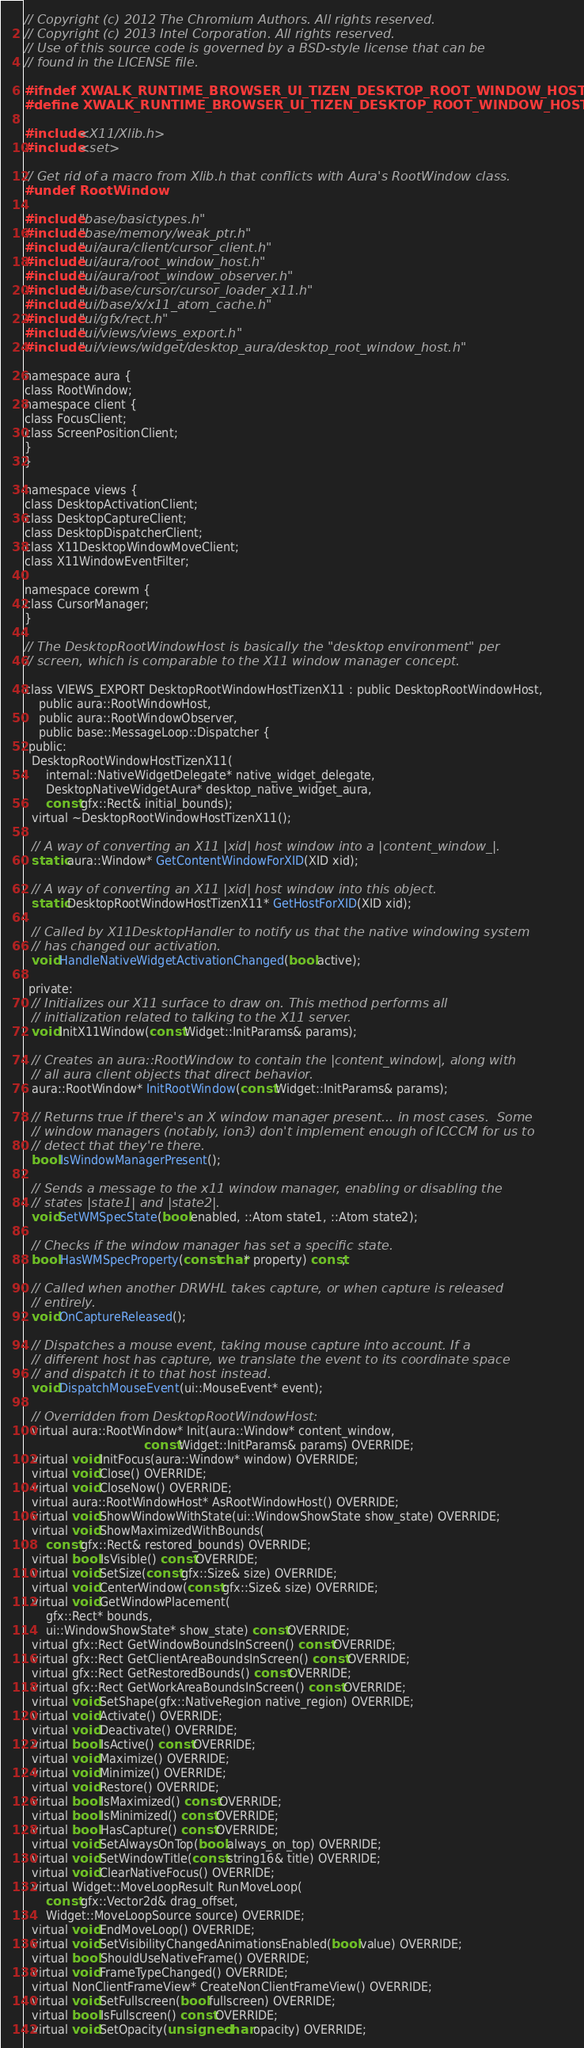<code> <loc_0><loc_0><loc_500><loc_500><_C_>// Copyright (c) 2012 The Chromium Authors. All rights reserved.
// Copyright (c) 2013 Intel Corporation. All rights reserved.
// Use of this source code is governed by a BSD-style license that can be
// found in the LICENSE file.

#ifndef XWALK_RUNTIME_BROWSER_UI_TIZEN_DESKTOP_ROOT_WINDOW_HOST_TIZEN_X11_H_
#define XWALK_RUNTIME_BROWSER_UI_TIZEN_DESKTOP_ROOT_WINDOW_HOST_TIZEN_X11_H_

#include <X11/Xlib.h>
#include <set>

// Get rid of a macro from Xlib.h that conflicts with Aura's RootWindow class.
#undef RootWindow

#include "base/basictypes.h"
#include "base/memory/weak_ptr.h"
#include "ui/aura/client/cursor_client.h"
#include "ui/aura/root_window_host.h"
#include "ui/aura/root_window_observer.h"
#include "ui/base/cursor/cursor_loader_x11.h"
#include "ui/base/x/x11_atom_cache.h"
#include "ui/gfx/rect.h"
#include "ui/views/views_export.h"
#include "ui/views/widget/desktop_aura/desktop_root_window_host.h"

namespace aura {
class RootWindow;
namespace client {
class FocusClient;
class ScreenPositionClient;
}
}

namespace views {
class DesktopActivationClient;
class DesktopCaptureClient;
class DesktopDispatcherClient;
class X11DesktopWindowMoveClient;
class X11WindowEventFilter;

namespace corewm {
class CursorManager;
}

// The DesktopRootWindowHost is basically the "desktop environment" per
// screen, which is comparable to the X11 window manager concept.

class VIEWS_EXPORT DesktopRootWindowHostTizenX11 : public DesktopRootWindowHost,
    public aura::RootWindowHost,
    public aura::RootWindowObserver,
    public base::MessageLoop::Dispatcher {
 public:
  DesktopRootWindowHostTizenX11(
      internal::NativeWidgetDelegate* native_widget_delegate,
      DesktopNativeWidgetAura* desktop_native_widget_aura,
      const gfx::Rect& initial_bounds);
  virtual ~DesktopRootWindowHostTizenX11();

  // A way of converting an X11 |xid| host window into a |content_window_|.
  static aura::Window* GetContentWindowForXID(XID xid);

  // A way of converting an X11 |xid| host window into this object.
  static DesktopRootWindowHostTizenX11* GetHostForXID(XID xid);

  // Called by X11DesktopHandler to notify us that the native windowing system
  // has changed our activation.
  void HandleNativeWidgetActivationChanged(bool active);

 private:
  // Initializes our X11 surface to draw on. This method performs all
  // initialization related to talking to the X11 server.
  void InitX11Window(const Widget::InitParams& params);

  // Creates an aura::RootWindow to contain the |content_window|, along with
  // all aura client objects that direct behavior.
  aura::RootWindow* InitRootWindow(const Widget::InitParams& params);

  // Returns true if there's an X window manager present... in most cases.  Some
  // window managers (notably, ion3) don't implement enough of ICCCM for us to
  // detect that they're there.
  bool IsWindowManagerPresent();

  // Sends a message to the x11 window manager, enabling or disabling the
  // states |state1| and |state2|.
  void SetWMSpecState(bool enabled, ::Atom state1, ::Atom state2);

  // Checks if the window manager has set a specific state.
  bool HasWMSpecProperty(const char* property) const;

  // Called when another DRWHL takes capture, or when capture is released
  // entirely.
  void OnCaptureReleased();

  // Dispatches a mouse event, taking mouse capture into account. If a
  // different host has capture, we translate the event to its coordinate space
  // and dispatch it to that host instead.
  void DispatchMouseEvent(ui::MouseEvent* event);

  // Overridden from DesktopRootWindowHost:
  virtual aura::RootWindow* Init(aura::Window* content_window,
                                 const Widget::InitParams& params) OVERRIDE;
  virtual void InitFocus(aura::Window* window) OVERRIDE;
  virtual void Close() OVERRIDE;
  virtual void CloseNow() OVERRIDE;
  virtual aura::RootWindowHost* AsRootWindowHost() OVERRIDE;
  virtual void ShowWindowWithState(ui::WindowShowState show_state) OVERRIDE;
  virtual void ShowMaximizedWithBounds(
      const gfx::Rect& restored_bounds) OVERRIDE;
  virtual bool IsVisible() const OVERRIDE;
  virtual void SetSize(const gfx::Size& size) OVERRIDE;
  virtual void CenterWindow(const gfx::Size& size) OVERRIDE;
  virtual void GetWindowPlacement(
      gfx::Rect* bounds,
      ui::WindowShowState* show_state) const OVERRIDE;
  virtual gfx::Rect GetWindowBoundsInScreen() const OVERRIDE;
  virtual gfx::Rect GetClientAreaBoundsInScreen() const OVERRIDE;
  virtual gfx::Rect GetRestoredBounds() const OVERRIDE;
  virtual gfx::Rect GetWorkAreaBoundsInScreen() const OVERRIDE;
  virtual void SetShape(gfx::NativeRegion native_region) OVERRIDE;
  virtual void Activate() OVERRIDE;
  virtual void Deactivate() OVERRIDE;
  virtual bool IsActive() const OVERRIDE;
  virtual void Maximize() OVERRIDE;
  virtual void Minimize() OVERRIDE;
  virtual void Restore() OVERRIDE;
  virtual bool IsMaximized() const OVERRIDE;
  virtual bool IsMinimized() const OVERRIDE;
  virtual bool HasCapture() const OVERRIDE;
  virtual void SetAlwaysOnTop(bool always_on_top) OVERRIDE;
  virtual void SetWindowTitle(const string16& title) OVERRIDE;
  virtual void ClearNativeFocus() OVERRIDE;
  virtual Widget::MoveLoopResult RunMoveLoop(
      const gfx::Vector2d& drag_offset,
      Widget::MoveLoopSource source) OVERRIDE;
  virtual void EndMoveLoop() OVERRIDE;
  virtual void SetVisibilityChangedAnimationsEnabled(bool value) OVERRIDE;
  virtual bool ShouldUseNativeFrame() OVERRIDE;
  virtual void FrameTypeChanged() OVERRIDE;
  virtual NonClientFrameView* CreateNonClientFrameView() OVERRIDE;
  virtual void SetFullscreen(bool fullscreen) OVERRIDE;
  virtual bool IsFullscreen() const OVERRIDE;
  virtual void SetOpacity(unsigned char opacity) OVERRIDE;</code> 